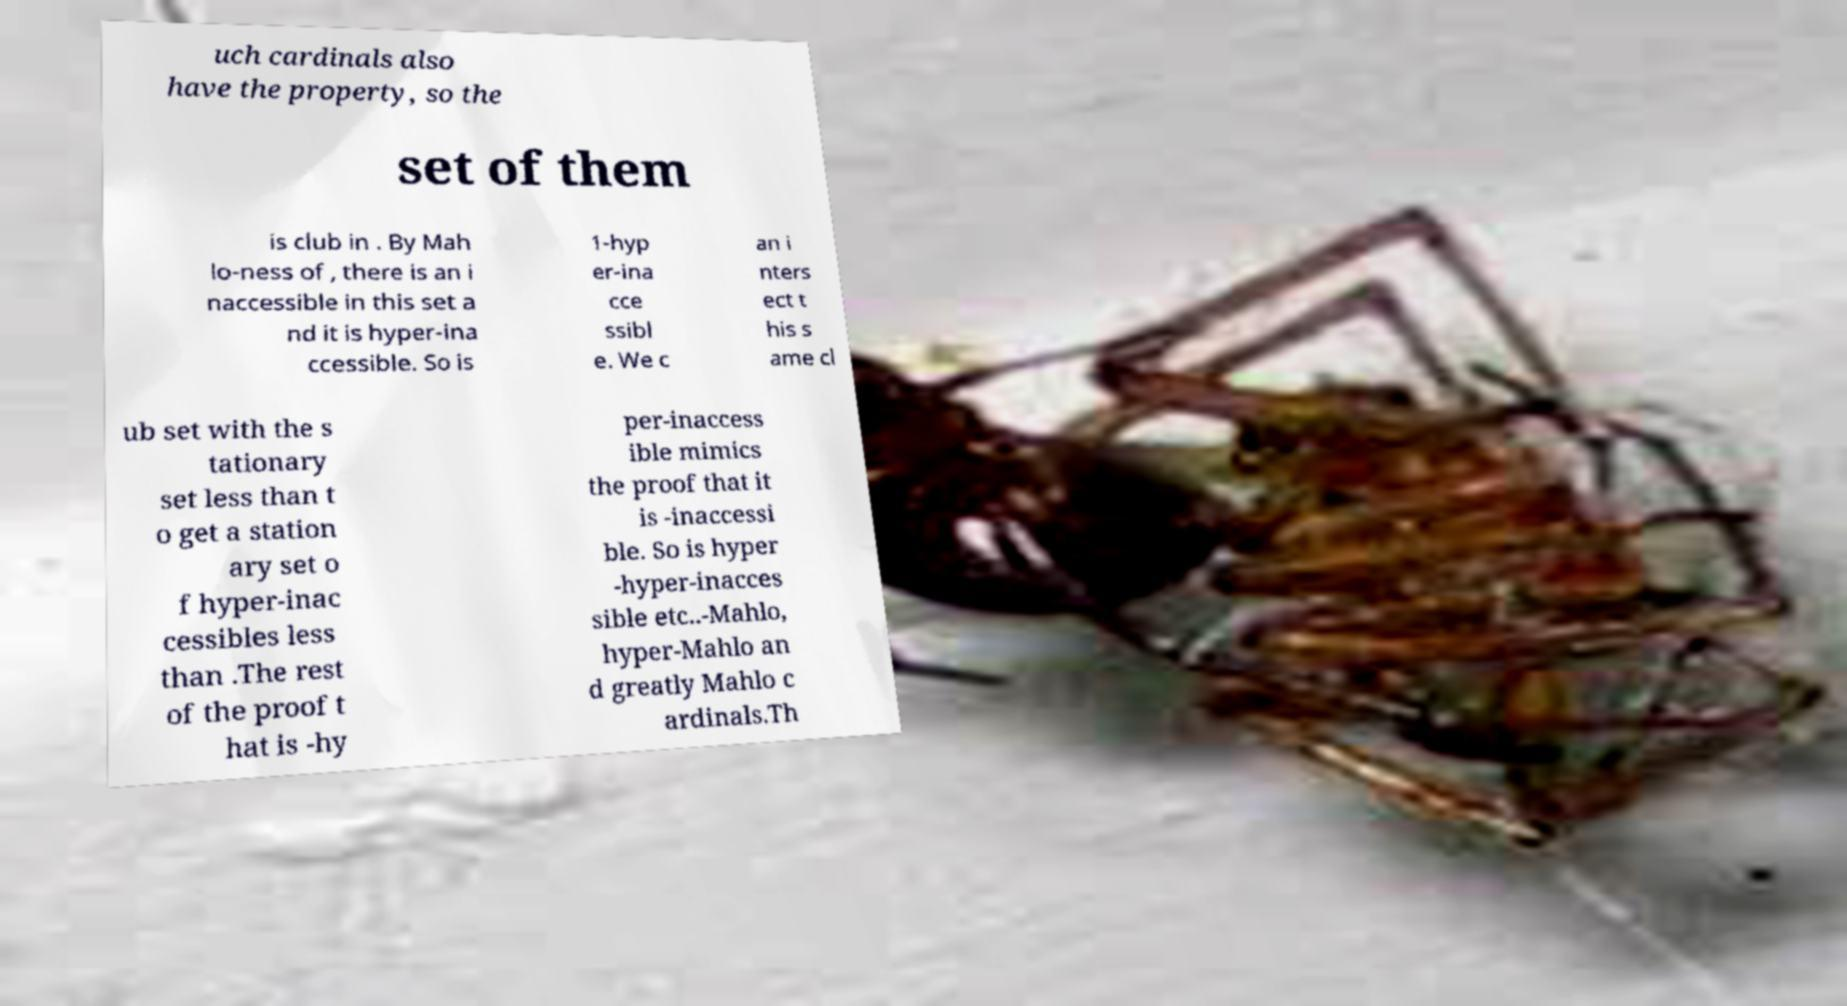Can you read and provide the text displayed in the image?This photo seems to have some interesting text. Can you extract and type it out for me? uch cardinals also have the property, so the set of them is club in . By Mah lo-ness of , there is an i naccessible in this set a nd it is hyper-ina ccessible. So is 1-hyp er-ina cce ssibl e. We c an i nters ect t his s ame cl ub set with the s tationary set less than t o get a station ary set o f hyper-inac cessibles less than .The rest of the proof t hat is -hy per-inaccess ible mimics the proof that it is -inaccessi ble. So is hyper -hyper-inacces sible etc..-Mahlo, hyper-Mahlo an d greatly Mahlo c ardinals.Th 